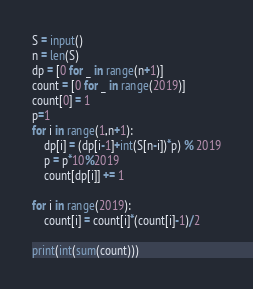<code> <loc_0><loc_0><loc_500><loc_500><_Python_>S = input()
n = len(S)
dp = [0 for _ in range(n+1)]
count = [0 for _ in range(2019)]
count[0] = 1
p=1
for i in range(1,n+1):
    dp[i] = (dp[i-1]+int(S[n-i])*p) % 2019
    p = p*10%2019
    count[dp[i]] += 1

for i in range(2019):
    count[i] = count[i]*(count[i]-1)/2

print(int(sum(count)))</code> 